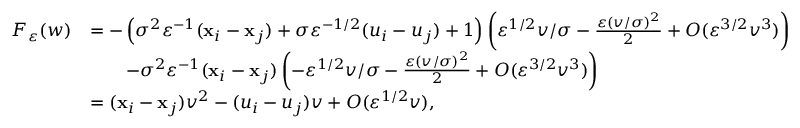Convert formula to latex. <formula><loc_0><loc_0><loc_500><loc_500>\begin{array} { r l } { F _ { \varepsilon } ( w ) } & { = - \left ( \sigma ^ { 2 } \varepsilon ^ { - 1 } ( x _ { i } - x _ { j } ) + \sigma \varepsilon ^ { - 1 / 2 } ( u _ { i } - u _ { j } ) + 1 \right ) \left ( \varepsilon ^ { 1 / 2 } v / \sigma - \frac { \varepsilon ( v / \sigma ) ^ { 2 } } { 2 } + O ( \varepsilon ^ { 3 / 2 } v ^ { 3 } ) \right ) } \\ & { \quad - \sigma ^ { 2 } \varepsilon ^ { - 1 } ( x _ { i } - x _ { j } ) \left ( - \varepsilon ^ { 1 / 2 } v / \sigma - \frac { \varepsilon ( v / \sigma ) ^ { 2 } } { 2 } + O ( \varepsilon ^ { 3 / 2 } v ^ { 3 } ) \right ) } \\ & { = ( x _ { i } - x _ { j } ) v ^ { 2 } - ( u _ { i } - u _ { j } ) v + O ( \varepsilon ^ { 1 / 2 } v ) , } \end{array}</formula> 